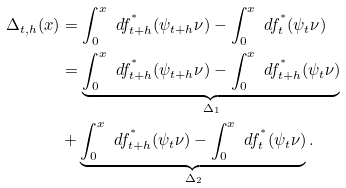Convert formula to latex. <formula><loc_0><loc_0><loc_500><loc_500>\Delta _ { t , h } ( x ) & = \int _ { 0 } ^ { x } \ d f _ { t + h } ^ { ^ { * } } ( \psi _ { t + h } \nu ) - \int _ { 0 } ^ { x } \ d f _ { t } ^ { ^ { * } } ( \psi _ { t } \nu ) \\ & = \underbrace { \int _ { 0 } ^ { x } \ d f _ { t + h } ^ { ^ { * } } ( \psi _ { t + h } \nu ) - \int _ { 0 } ^ { x } \ d f _ { t + h } ^ { ^ { * } } ( \psi _ { t } \nu ) } _ { \Delta _ { 1 } } \\ & + \underbrace { \int _ { 0 } ^ { x } \ d f _ { t + h } ^ { ^ { * } } ( \psi _ { t } \nu ) - \int _ { 0 } ^ { x } \ d f _ { t } ^ { ^ { * } } ( \psi _ { t } \nu ) } _ { \Delta _ { 2 } } .</formula> 